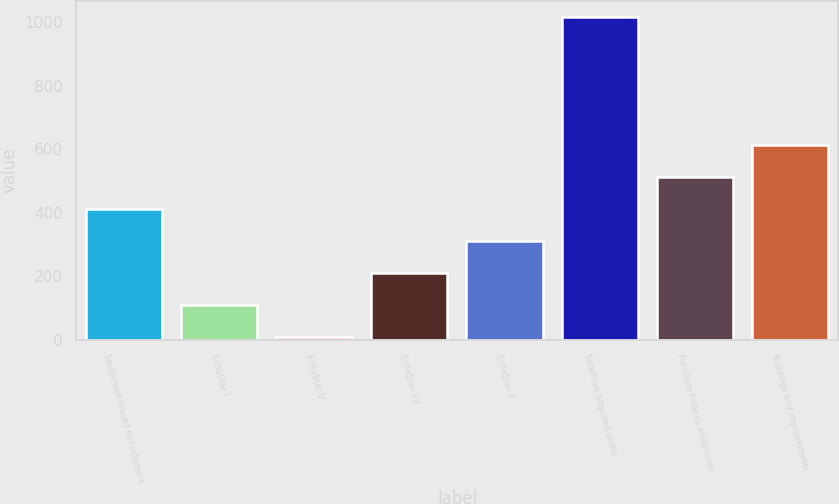<chart> <loc_0><loc_0><loc_500><loc_500><bar_chart><fcel>Equipment leased to customers<fcel>EchoStar I<fcel>EchoStar V<fcel>EchoStar VII<fcel>EchoStar X<fcel>Satellites acquired under<fcel>Furniture fixtures equipment<fcel>Buildings and improvements<nl><fcel>411.4<fcel>109.6<fcel>9<fcel>210.2<fcel>310.8<fcel>1015<fcel>512<fcel>612.6<nl></chart> 